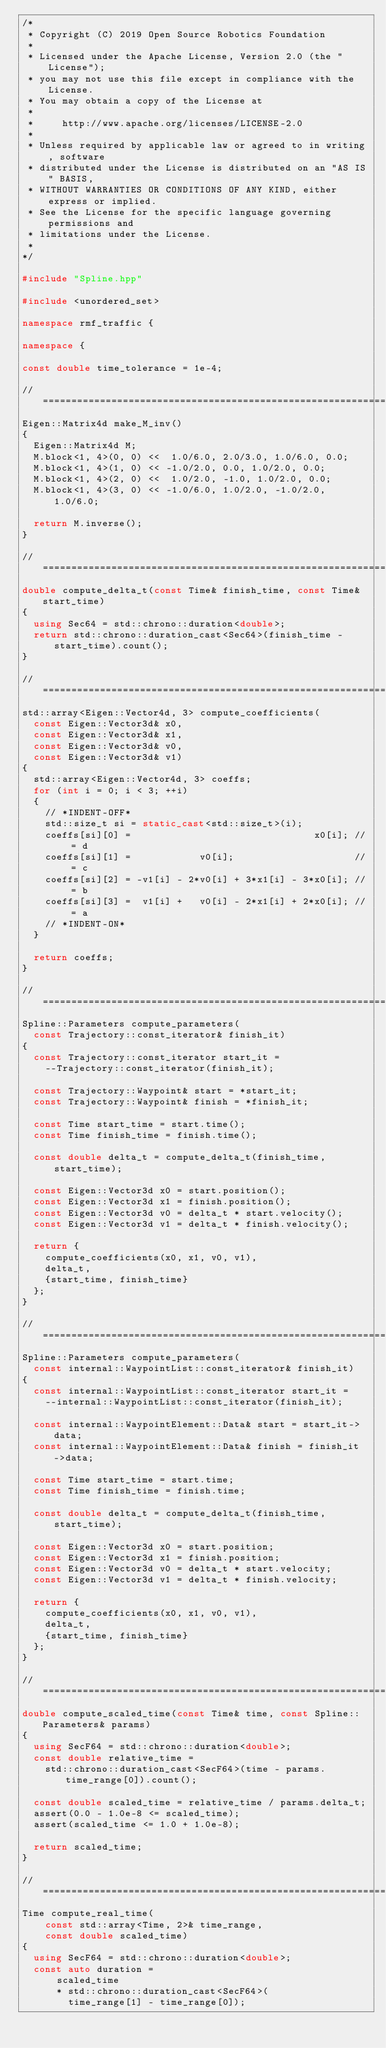Convert code to text. <code><loc_0><loc_0><loc_500><loc_500><_C++_>/*
 * Copyright (C) 2019 Open Source Robotics Foundation
 *
 * Licensed under the Apache License, Version 2.0 (the "License");
 * you may not use this file except in compliance with the License.
 * You may obtain a copy of the License at
 *
 *     http://www.apache.org/licenses/LICENSE-2.0
 *
 * Unless required by applicable law or agreed to in writing, software
 * distributed under the License is distributed on an "AS IS" BASIS,
 * WITHOUT WARRANTIES OR CONDITIONS OF ANY KIND, either express or implied.
 * See the License for the specific language governing permissions and
 * limitations under the License.
 *
*/

#include "Spline.hpp"

#include <unordered_set>

namespace rmf_traffic {

namespace {

const double time_tolerance = 1e-4;

//==============================================================================
Eigen::Matrix4d make_M_inv()
{
  Eigen::Matrix4d M;
  M.block<1, 4>(0, 0) <<  1.0/6.0, 2.0/3.0, 1.0/6.0, 0.0;
  M.block<1, 4>(1, 0) << -1.0/2.0, 0.0, 1.0/2.0, 0.0;
  M.block<1, 4>(2, 0) <<  1.0/2.0, -1.0, 1.0/2.0, 0.0;
  M.block<1, 4>(3, 0) << -1.0/6.0, 1.0/2.0, -1.0/2.0, 1.0/6.0;

  return M.inverse();
}

//==============================================================================
double compute_delta_t(const Time& finish_time, const Time& start_time)
{
  using Sec64 = std::chrono::duration<double>;
  return std::chrono::duration_cast<Sec64>(finish_time - start_time).count();
}

//==============================================================================
std::array<Eigen::Vector4d, 3> compute_coefficients(
  const Eigen::Vector3d& x0,
  const Eigen::Vector3d& x1,
  const Eigen::Vector3d& v0,
  const Eigen::Vector3d& v1)
{
  std::array<Eigen::Vector4d, 3> coeffs;
  for (int i = 0; i < 3; ++i)
  {
    // *INDENT-OFF*
    std::size_t si = static_cast<std::size_t>(i);
    coeffs[si][0] =                                x0[i]; // = d
    coeffs[si][1] =            v0[i];                     // = c
    coeffs[si][2] = -v1[i] - 2*v0[i] + 3*x1[i] - 3*x0[i]; // = b
    coeffs[si][3] =  v1[i] +   v0[i] - 2*x1[i] + 2*x0[i]; // = a
    // *INDENT-ON*
  }

  return coeffs;
}

//==============================================================================
Spline::Parameters compute_parameters(
  const Trajectory::const_iterator& finish_it)
{
  const Trajectory::const_iterator start_it =
    --Trajectory::const_iterator(finish_it);

  const Trajectory::Waypoint& start = *start_it;
  const Trajectory::Waypoint& finish = *finish_it;

  const Time start_time = start.time();
  const Time finish_time = finish.time();

  const double delta_t = compute_delta_t(finish_time, start_time);

  const Eigen::Vector3d x0 = start.position();
  const Eigen::Vector3d x1 = finish.position();
  const Eigen::Vector3d v0 = delta_t * start.velocity();
  const Eigen::Vector3d v1 = delta_t * finish.velocity();

  return {
    compute_coefficients(x0, x1, v0, v1),
    delta_t,
    {start_time, finish_time}
  };
}

//==============================================================================
Spline::Parameters compute_parameters(
  const internal::WaypointList::const_iterator& finish_it)
{
  const internal::WaypointList::const_iterator start_it =
    --internal::WaypointList::const_iterator(finish_it);

  const internal::WaypointElement::Data& start = start_it->data;
  const internal::WaypointElement::Data& finish = finish_it->data;

  const Time start_time = start.time;
  const Time finish_time = finish.time;

  const double delta_t = compute_delta_t(finish_time, start_time);

  const Eigen::Vector3d x0 = start.position;
  const Eigen::Vector3d x1 = finish.position;
  const Eigen::Vector3d v0 = delta_t * start.velocity;
  const Eigen::Vector3d v1 = delta_t * finish.velocity;

  return {
    compute_coefficients(x0, x1, v0, v1),
    delta_t,
    {start_time, finish_time}
  };
}

//==============================================================================
double compute_scaled_time(const Time& time, const Spline::Parameters& params)
{
  using SecF64 = std::chrono::duration<double>;
  const double relative_time =
    std::chrono::duration_cast<SecF64>(time - params.time_range[0]).count();

  const double scaled_time = relative_time / params.delta_t;
  assert(0.0 - 1.0e-8 <= scaled_time);
  assert(scaled_time <= 1.0 + 1.0e-8);

  return scaled_time;
}

//==============================================================================
Time compute_real_time(
    const std::array<Time, 2>& time_range,
    const double scaled_time)
{
  using SecF64 = std::chrono::duration<double>;
  const auto duration =
      scaled_time
      * std::chrono::duration_cast<SecF64>(
        time_range[1] - time_range[0]);
</code> 